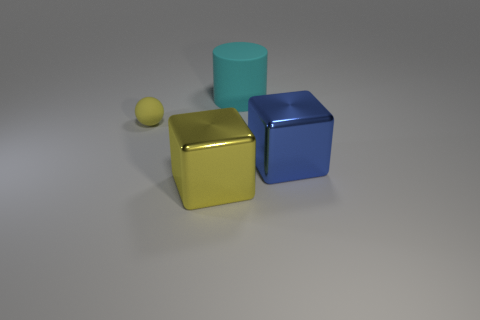Add 2 blue metal objects. How many objects exist? 6 Subtract 1 cubes. How many cubes are left? 1 Subtract all yellow blocks. How many blocks are left? 1 Subtract all balls. How many objects are left? 3 Subtract all matte cubes. Subtract all large metal blocks. How many objects are left? 2 Add 2 big yellow things. How many big yellow things are left? 3 Add 4 big green metallic things. How many big green metallic things exist? 4 Subtract 0 brown cubes. How many objects are left? 4 Subtract all purple cubes. Subtract all purple spheres. How many cubes are left? 2 Subtract all yellow balls. How many yellow blocks are left? 1 